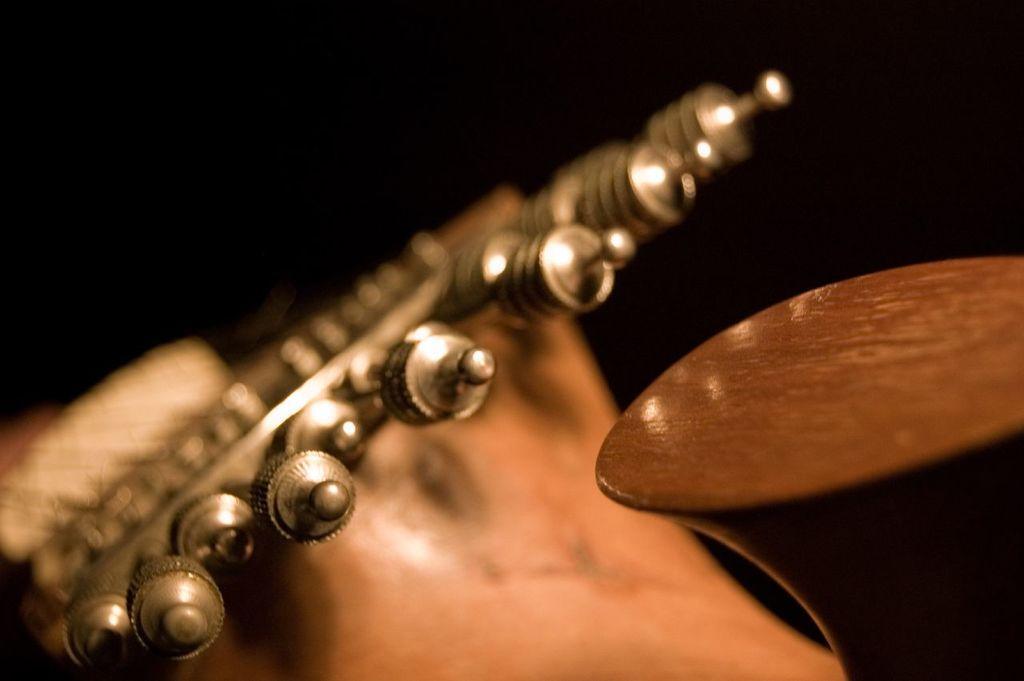Could you give a brief overview of what you see in this image? This is a macro image and it consists of an object which looks like a musical instrument. 